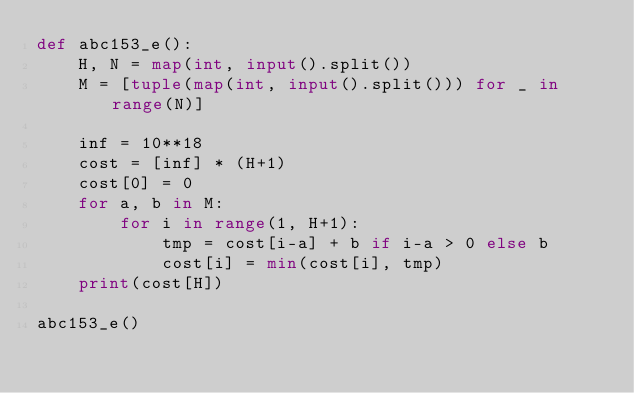Convert code to text. <code><loc_0><loc_0><loc_500><loc_500><_Python_>def abc153_e():
    H, N = map(int, input().split())
    M = [tuple(map(int, input().split())) for _ in range(N)]

    inf = 10**18
    cost = [inf] * (H+1)
    cost[0] = 0
    for a, b in M:
        for i in range(1, H+1):
            tmp = cost[i-a] + b if i-a > 0 else b
            cost[i] = min(cost[i], tmp)
    print(cost[H])

abc153_e()</code> 